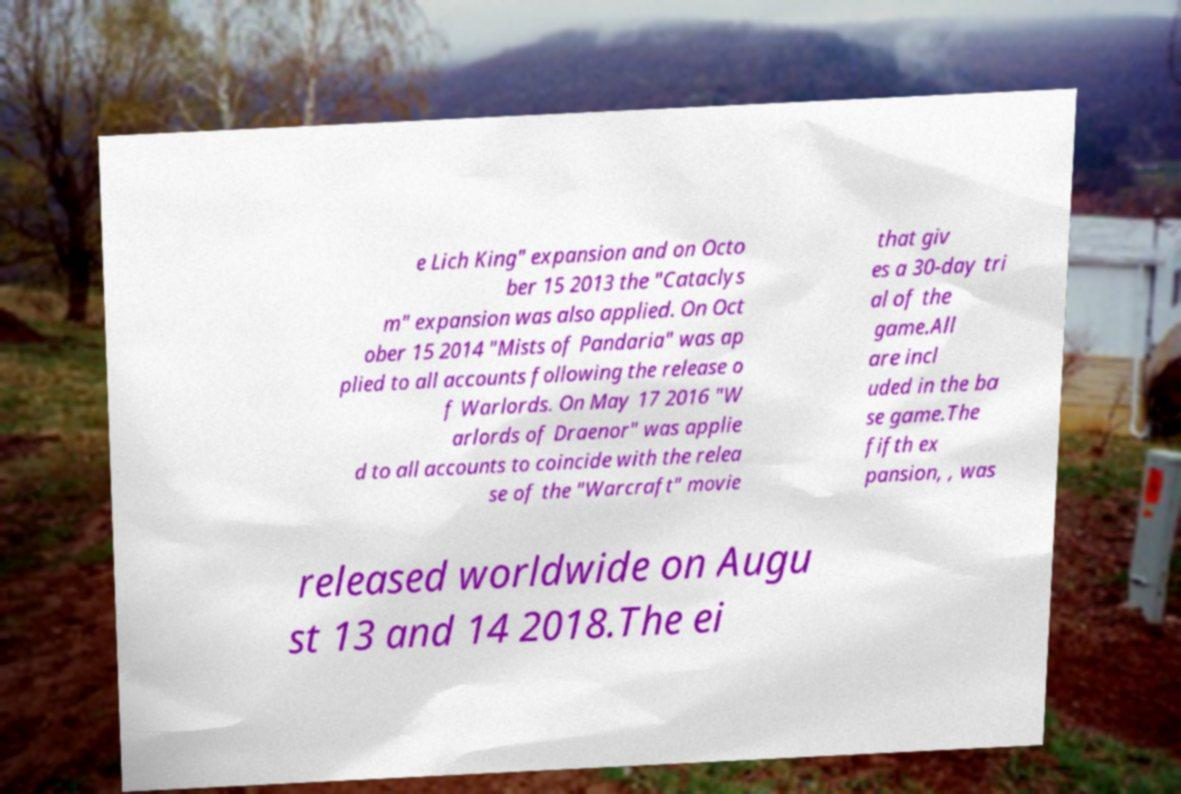Could you assist in decoding the text presented in this image and type it out clearly? e Lich King" expansion and on Octo ber 15 2013 the "Cataclys m" expansion was also applied. On Oct ober 15 2014 "Mists of Pandaria" was ap plied to all accounts following the release o f Warlords. On May 17 2016 "W arlords of Draenor" was applie d to all accounts to coincide with the relea se of the "Warcraft" movie that giv es a 30-day tri al of the game.All are incl uded in the ba se game.The fifth ex pansion, , was released worldwide on Augu st 13 and 14 2018.The ei 